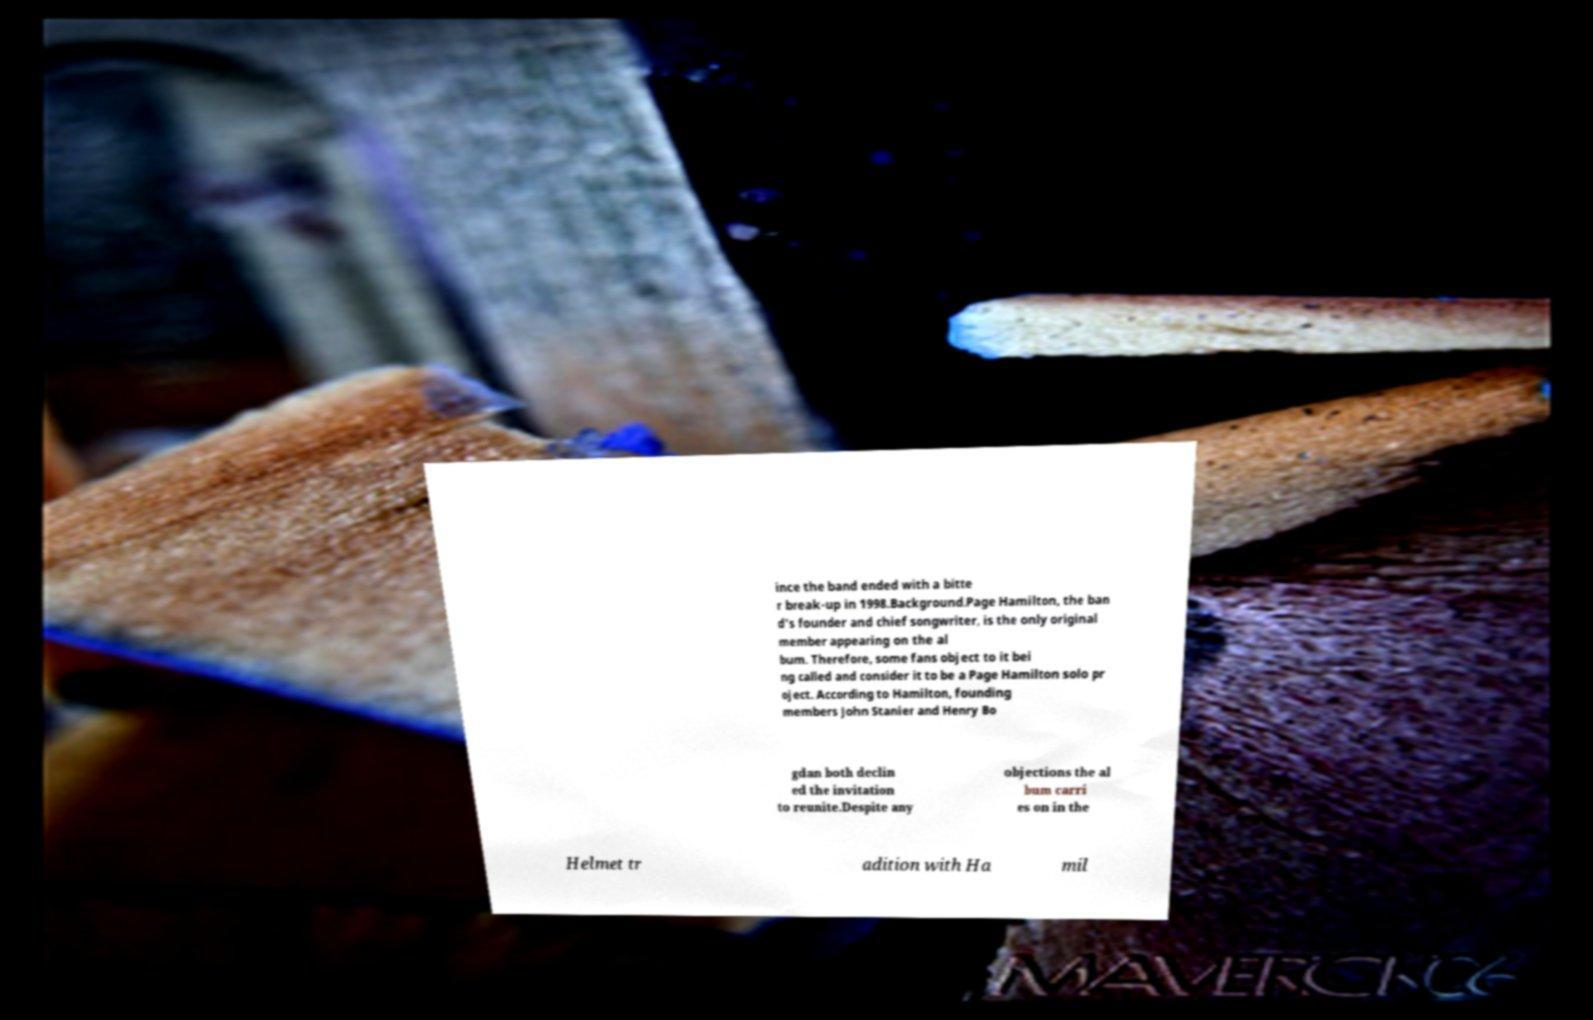Can you accurately transcribe the text from the provided image for me? ince the band ended with a bitte r break-up in 1998.Background.Page Hamilton, the ban d's founder and chief songwriter, is the only original member appearing on the al bum. Therefore, some fans object to it bei ng called and consider it to be a Page Hamilton solo pr oject. According to Hamilton, founding members John Stanier and Henry Bo gdan both declin ed the invitation to reunite.Despite any objections the al bum carri es on in the Helmet tr adition with Ha mil 